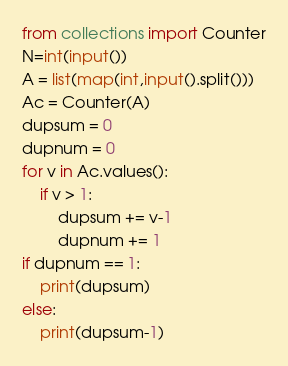<code> <loc_0><loc_0><loc_500><loc_500><_Python_>from collections import Counter
N=int(input())
A = list(map(int,input().split()))
Ac = Counter(A)
dupsum = 0
dupnum = 0
for v in Ac.values():
    if v > 1:
        dupsum += v-1
        dupnum += 1
if dupnum == 1:
    print(dupsum)
else:
    print(dupsum-1)</code> 